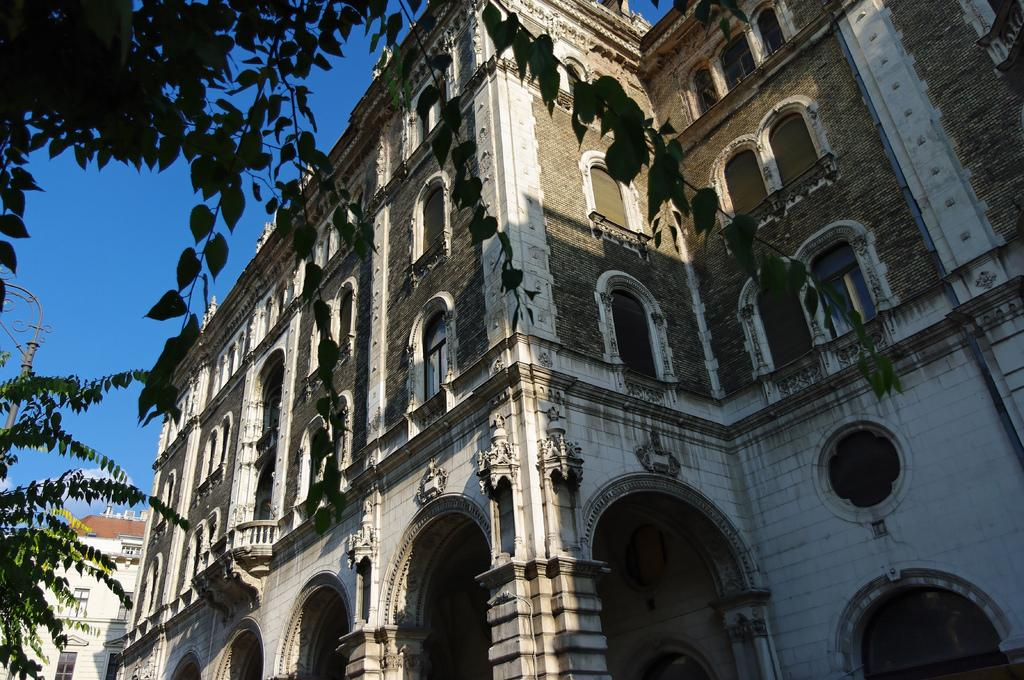What type of structures can be seen in the image? There are buildings in the image. What is located on the left side of the image? There is a pole and a tree on the left side of the image. What can be seen in the background of the image? The sky is visible in the background of the image. What type of prose is being recited by the tree in the image? There is no prose being recited by the tree in the image, as trees do not have the ability to speak or recite prose. 